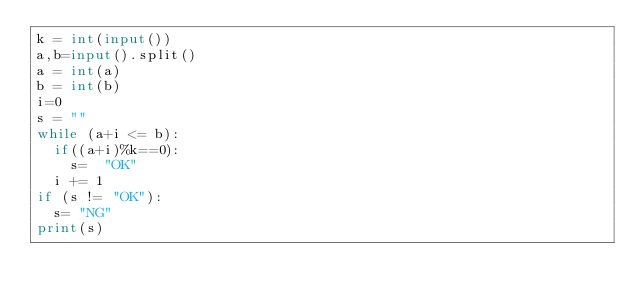Convert code to text. <code><loc_0><loc_0><loc_500><loc_500><_Python_>k = int(input())
a,b=input().split()
a = int(a)
b = int(b)
i=0
s = ""
while (a+i <= b):
  if((a+i)%k==0):
  	s=  "OK"
  i += 1
if (s != "OK"):
	s= "NG"
print(s)</code> 